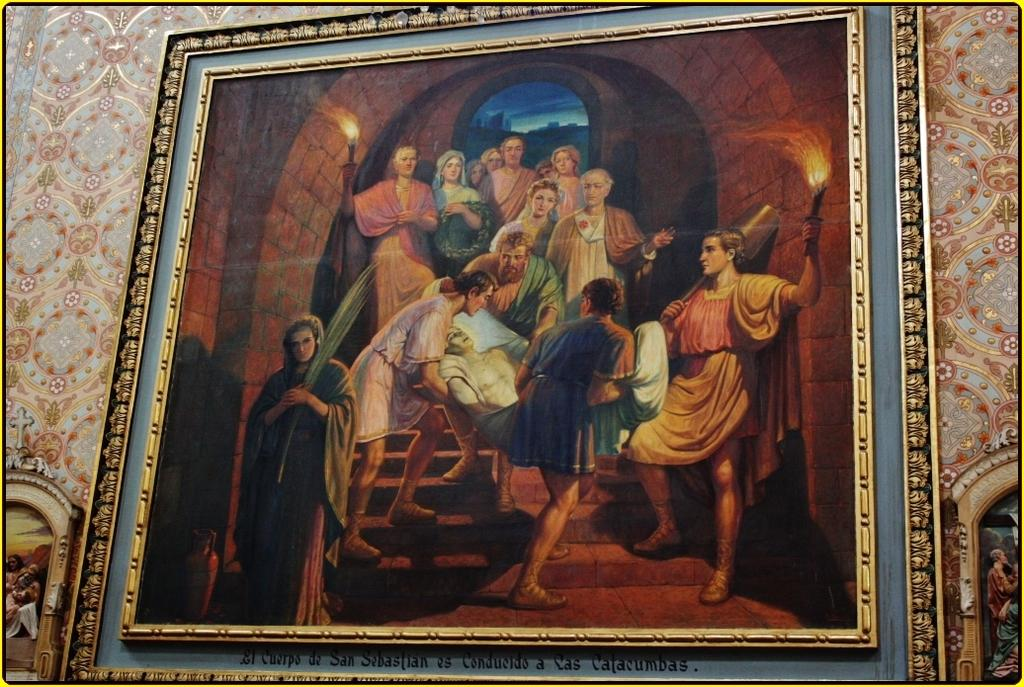What is hanging on the wall in the image? There is a painting with a frame on the wall in the image. What can be seen in the background of the image? There is a wall in the background of the image. Where are more paintings with frames located in the image? There are paintings with frames on the left side and the right side of the image. What type of volcano can be seen erupting in the image? There is no volcano present in the image; it features paintings with frames on the wall and surrounding areas. 